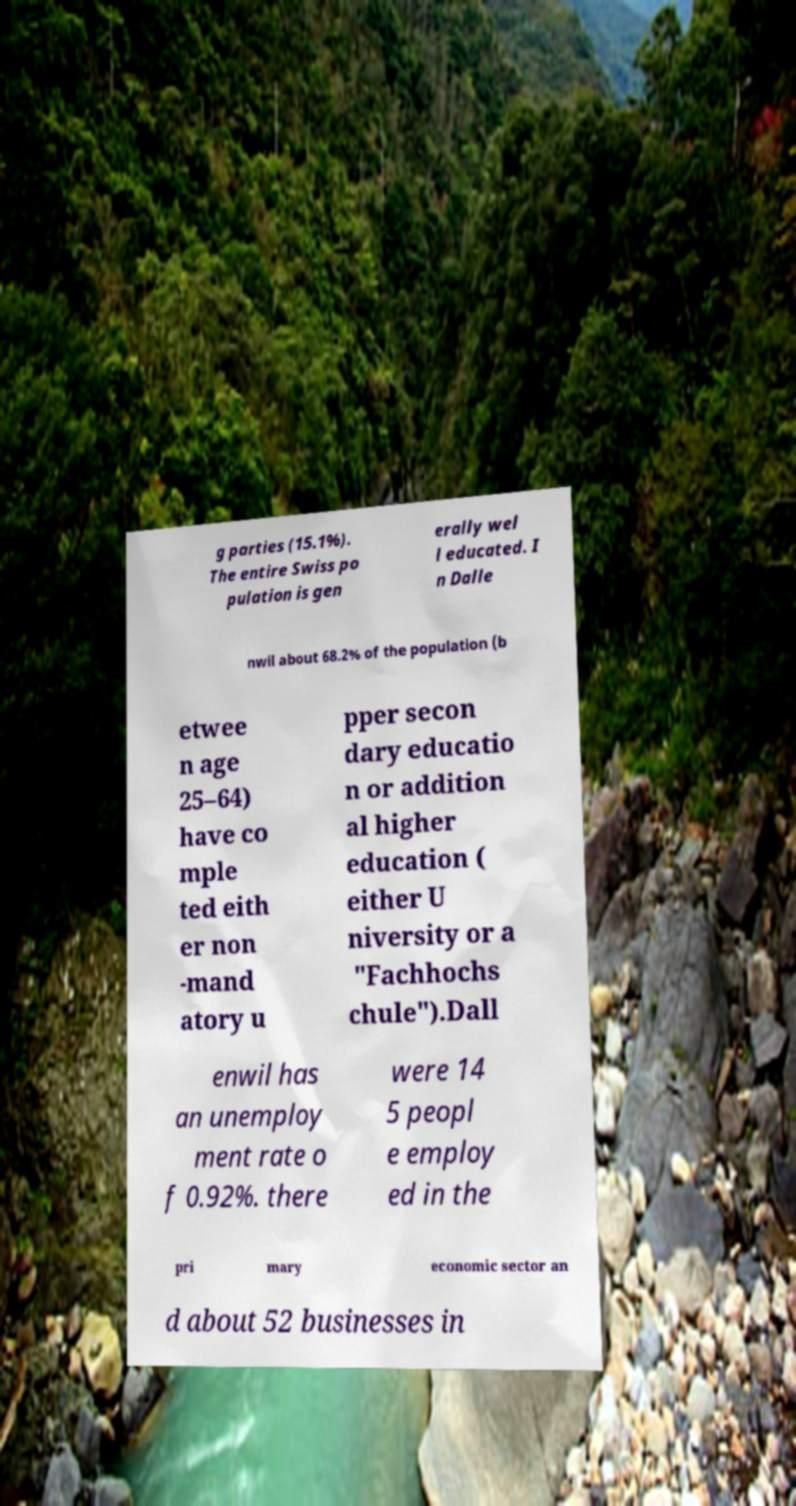Can you read and provide the text displayed in the image?This photo seems to have some interesting text. Can you extract and type it out for me? g parties (15.1%). The entire Swiss po pulation is gen erally wel l educated. I n Dalle nwil about 68.2% of the population (b etwee n age 25–64) have co mple ted eith er non -mand atory u pper secon dary educatio n or addition al higher education ( either U niversity or a "Fachhochs chule").Dall enwil has an unemploy ment rate o f 0.92%. there were 14 5 peopl e employ ed in the pri mary economic sector an d about 52 businesses in 